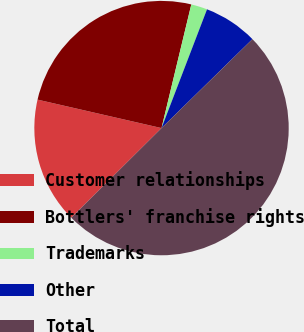<chart> <loc_0><loc_0><loc_500><loc_500><pie_chart><fcel>Customer relationships<fcel>Bottlers' franchise rights<fcel>Trademarks<fcel>Other<fcel>Total<nl><fcel>16.04%<fcel>25.17%<fcel>2.06%<fcel>6.85%<fcel>49.87%<nl></chart> 